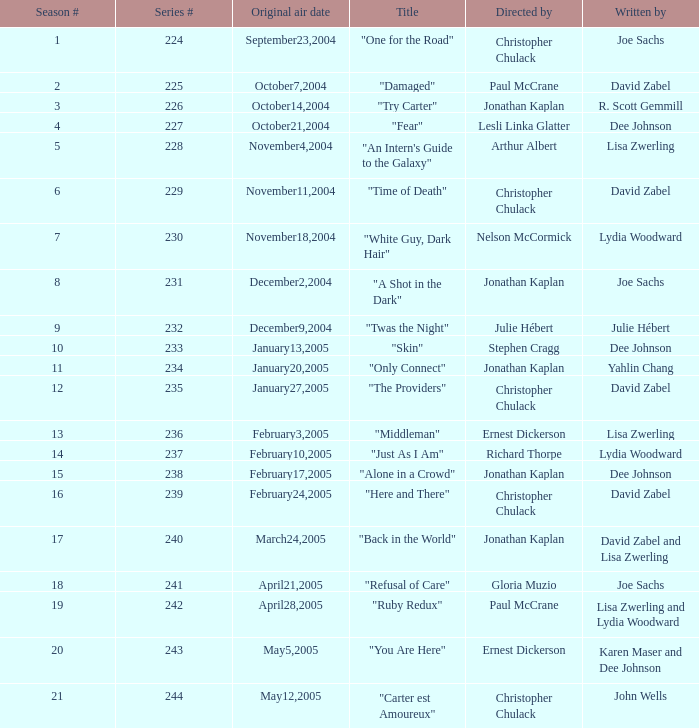Name who wrote the episode directed by arthur albert Lisa Zwerling. 